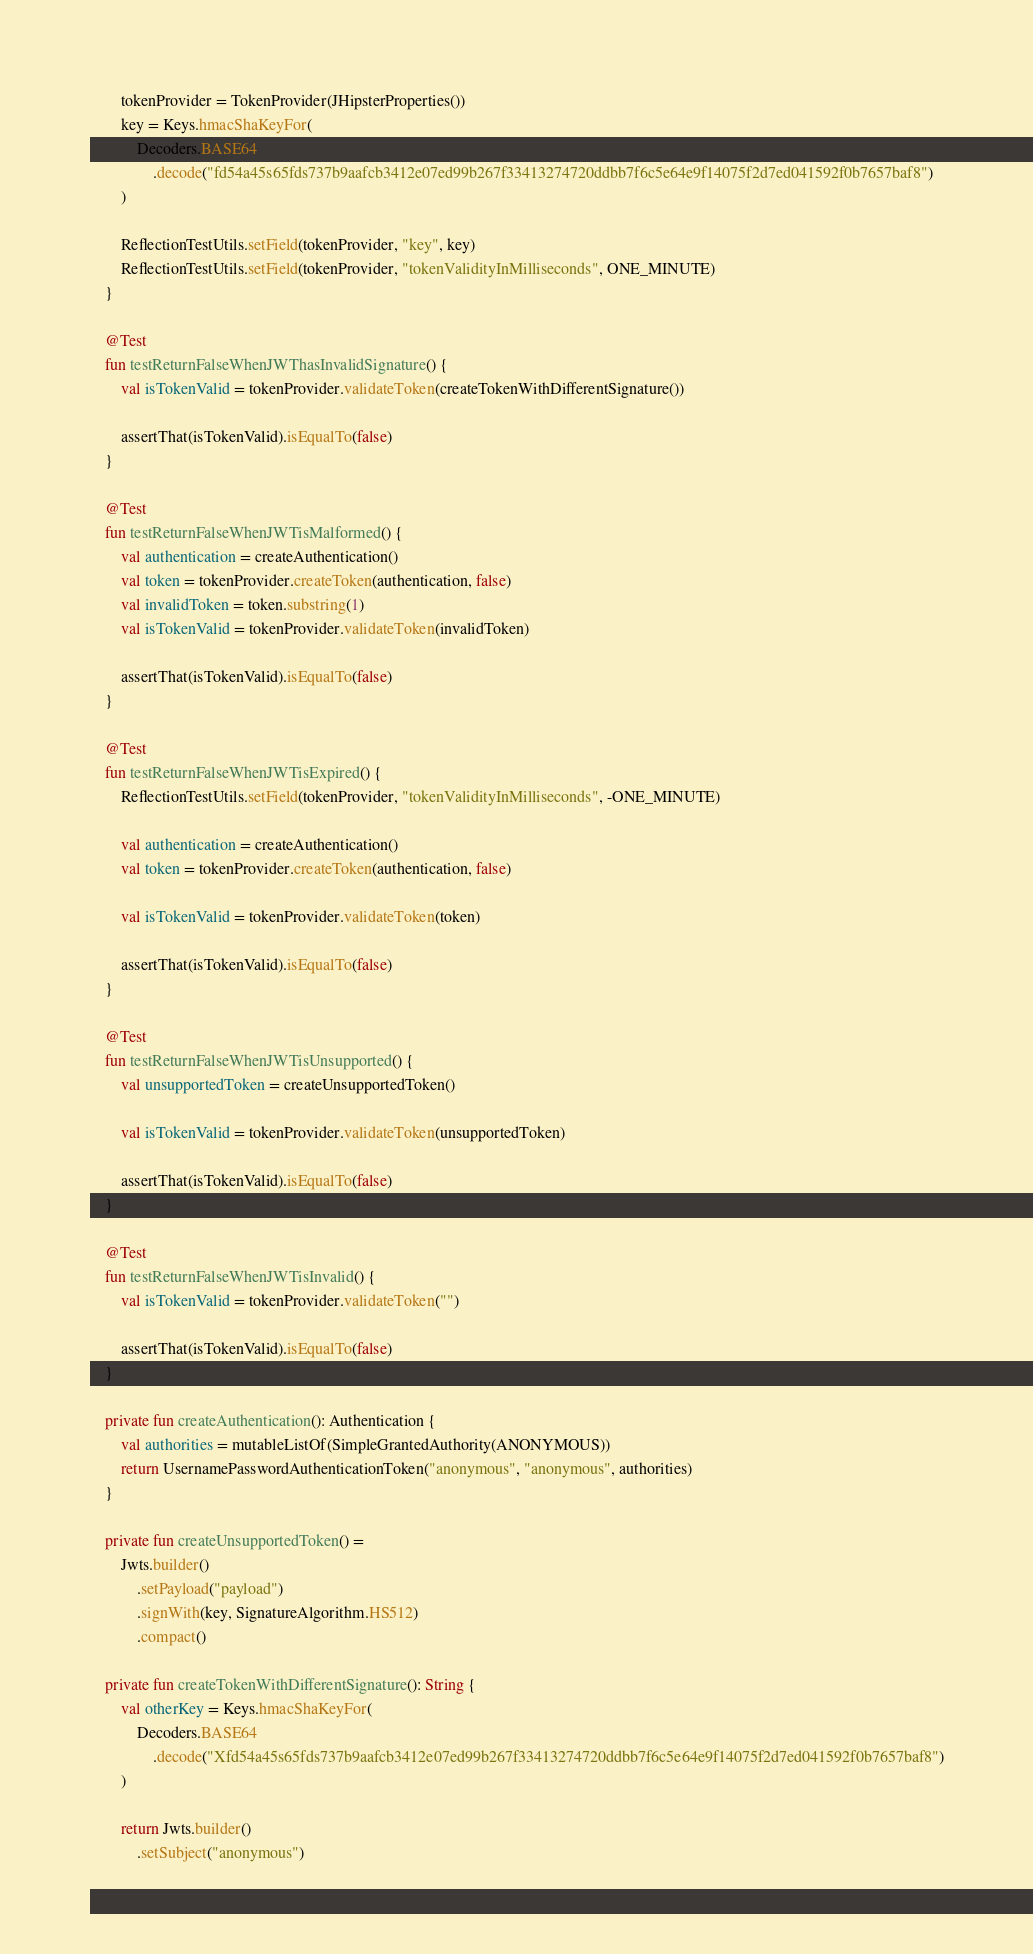<code> <loc_0><loc_0><loc_500><loc_500><_Kotlin_>        tokenProvider = TokenProvider(JHipsterProperties())
        key = Keys.hmacShaKeyFor(
            Decoders.BASE64
                .decode("fd54a45s65fds737b9aafcb3412e07ed99b267f33413274720ddbb7f6c5e64e9f14075f2d7ed041592f0b7657baf8")
        )

        ReflectionTestUtils.setField(tokenProvider, "key", key)
        ReflectionTestUtils.setField(tokenProvider, "tokenValidityInMilliseconds", ONE_MINUTE)
    }

    @Test
    fun testReturnFalseWhenJWThasInvalidSignature() {
        val isTokenValid = tokenProvider.validateToken(createTokenWithDifferentSignature())

        assertThat(isTokenValid).isEqualTo(false)
    }

    @Test
    fun testReturnFalseWhenJWTisMalformed() {
        val authentication = createAuthentication()
        val token = tokenProvider.createToken(authentication, false)
        val invalidToken = token.substring(1)
        val isTokenValid = tokenProvider.validateToken(invalidToken)

        assertThat(isTokenValid).isEqualTo(false)
    }

    @Test
    fun testReturnFalseWhenJWTisExpired() {
        ReflectionTestUtils.setField(tokenProvider, "tokenValidityInMilliseconds", -ONE_MINUTE)

        val authentication = createAuthentication()
        val token = tokenProvider.createToken(authentication, false)

        val isTokenValid = tokenProvider.validateToken(token)

        assertThat(isTokenValid).isEqualTo(false)
    }

    @Test
    fun testReturnFalseWhenJWTisUnsupported() {
        val unsupportedToken = createUnsupportedToken()

        val isTokenValid = tokenProvider.validateToken(unsupportedToken)

        assertThat(isTokenValid).isEqualTo(false)
    }

    @Test
    fun testReturnFalseWhenJWTisInvalid() {
        val isTokenValid = tokenProvider.validateToken("")

        assertThat(isTokenValid).isEqualTo(false)
    }

    private fun createAuthentication(): Authentication {
        val authorities = mutableListOf(SimpleGrantedAuthority(ANONYMOUS))
        return UsernamePasswordAuthenticationToken("anonymous", "anonymous", authorities)
    }

    private fun createUnsupportedToken() =
        Jwts.builder()
            .setPayload("payload")
            .signWith(key, SignatureAlgorithm.HS512)
            .compact()

    private fun createTokenWithDifferentSignature(): String {
        val otherKey = Keys.hmacShaKeyFor(
            Decoders.BASE64
                .decode("Xfd54a45s65fds737b9aafcb3412e07ed99b267f33413274720ddbb7f6c5e64e9f14075f2d7ed041592f0b7657baf8")
        )

        return Jwts.builder()
            .setSubject("anonymous")</code> 